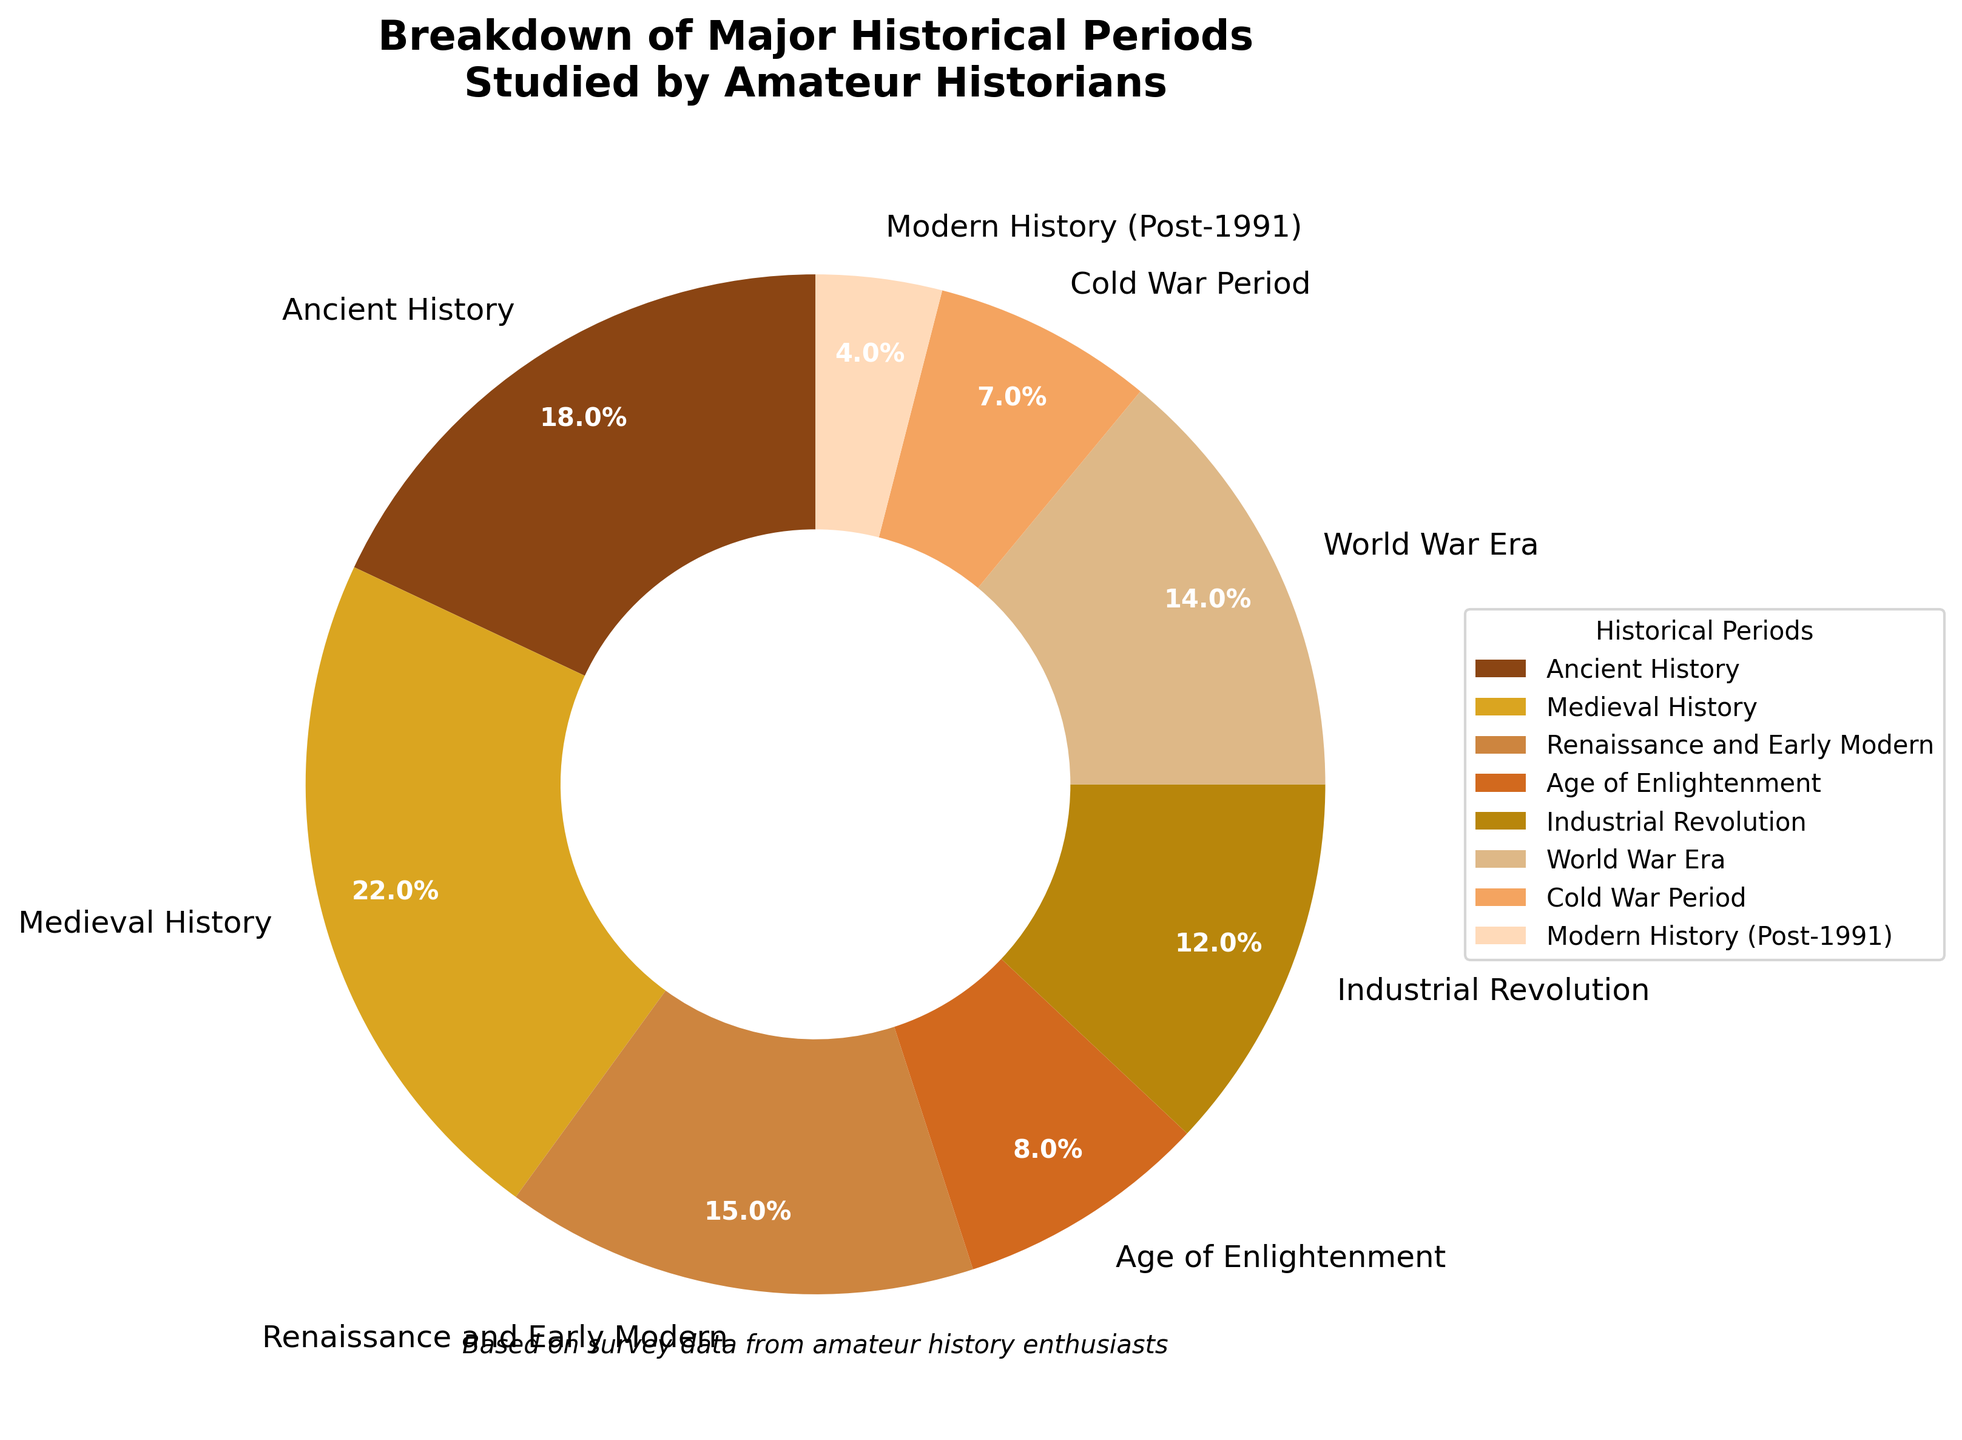What are the two most studied historical periods? To find the two most studied periods, we look for the two largest sections in the pie chart. The largest sections correspond to Medieval History and Ancient History.
Answer: Medieval History and Ancient History What is the total percentage of historians studying periods before the Renaissance? We need to sum the percentages of Ancient History and Medieval History. Ancient History is 18% and Medieval History is 22%. So, 18% + 22% = 40%.
Answer: 40% Which historical period has the smallest representation among amateur historians? The smallest section of the pie chart represents the Modern History (Post-1991) period.
Answer: Modern History (Post-1991) How much larger is the representation of the Medieval History period compared to the Age of Enlightenment? Medieval History is 22%, and the Age of Enlightenment is 8%. The difference is 22% - 8% = 14%.
Answer: 14% What is the combined percentage of historians studying the Age of Enlightenment and Cold War Period? To find the combined percentage, sum the percentages of the Age of Enlightenment and Cold War Period. Age of Enlightenment is 8% and Cold War Period is 7%. So, 8% + 7% = 15%.
Answer: 15% Which color represents the Industrial Revolution period? By referring to the color legend in the pie chart, we can see that the Industrial Revolution period is represented by a sandy brown color.
Answer: Sandy brown Is the percentage of amateur historians studying the World War Era greater than the percentage studying Renaissance and Early Modern periods? The World War Era is represented by 14%, while the Renaissance and Early Modern periods are represented by 15%. Since 14% is less than 15%, the percentage of those studying the World War Era is not greater.
Answer: No What is the difference in representation between the earliest historical period (Ancient History) and the latest historical period (Modern History Post-1991)? Ancient History is 18%, and Modern History (Post-1991) is 4%. The difference is 18% - 4% = 14%.
Answer: 14% What percentage of amateur historians study periods covering the Industrial Revolution and the World War Era combined? The Industrial Revolution is 12%, and the World War Era is 14%. The combined percentage is 12% + 14% = 26%.
Answer: 26% What's the average percentage of amateur historians studying the periods Renaissance and Early Modern, Industrial Revolution, and Cold War Period? The percentages are 15%, 12%, and 7% respectively. Adding these gives 15% + 12% + 7% = 34%. There are 3 periods, so the average is 34% / 3 = 11.33%.
Answer: 11.33% 